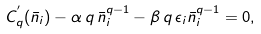<formula> <loc_0><loc_0><loc_500><loc_500>C _ { q } ^ { ^ { \prime } } ( \bar { n } _ { i } ) - \alpha \, q \, \bar { n } _ { i } ^ { q - 1 } - \beta \, q \, \epsilon _ { i } \bar { n } _ { i } ^ { q - 1 } = 0 ,</formula> 